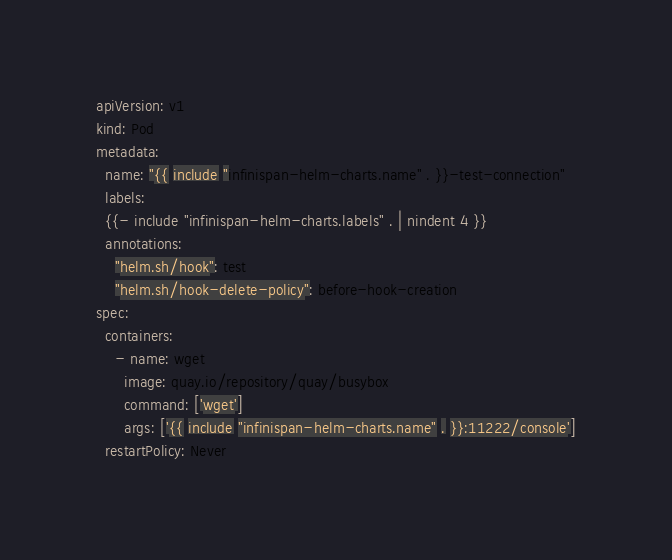Convert code to text. <code><loc_0><loc_0><loc_500><loc_500><_YAML_>apiVersion: v1
kind: Pod
metadata:
  name: "{{ include "infinispan-helm-charts.name" . }}-test-connection"
  labels:
  {{- include "infinispan-helm-charts.labels" . | nindent 4 }}
  annotations:
    "helm.sh/hook": test
    "helm.sh/hook-delete-policy": before-hook-creation
spec:
  containers:
    - name: wget
      image: quay.io/repository/quay/busybox
      command: ['wget']
      args: ['{{ include "infinispan-helm-charts.name" . }}:11222/console']
  restartPolicy: Never
</code> 